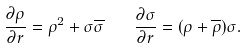<formula> <loc_0><loc_0><loc_500><loc_500>\frac { \partial \rho } { \partial r } = \rho ^ { 2 } + \sigma \overline { \sigma } \quad \frac { \partial \sigma } { \partial r } = ( \rho + \overline { \rho } ) \sigma .</formula> 